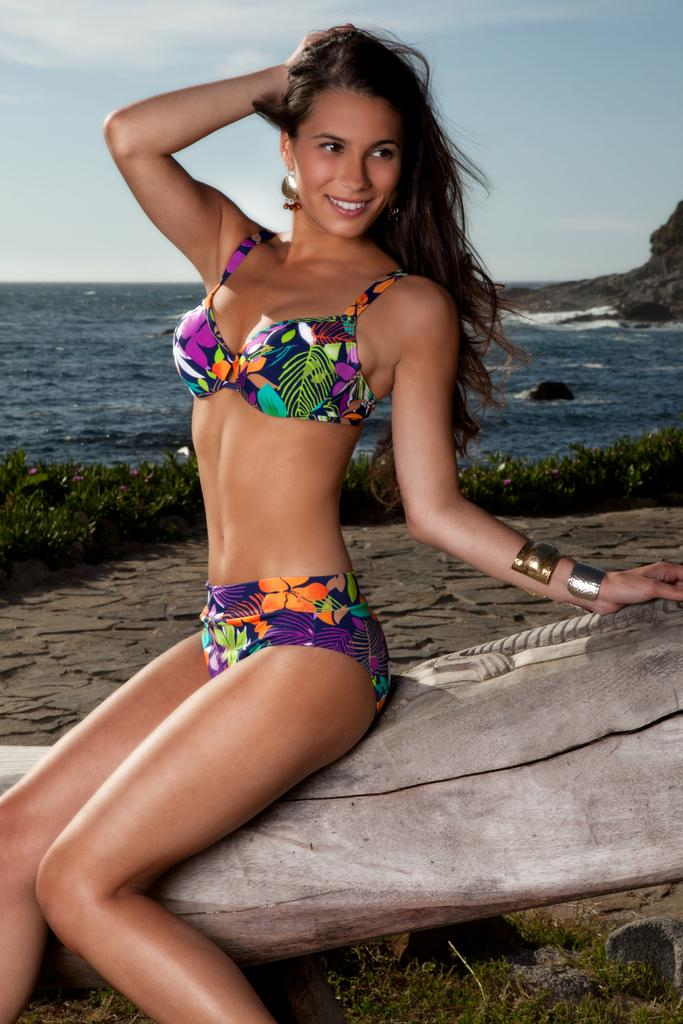Who is present in the image? There is a woman in the image. What is the woman doing in the image? The woman is sitting on a branch. What is the woman's facial expression in the image? The woman is smiling. What can be seen in the background of the image? There is sky, grass, and water visible in the background of the image. What suggestion does the woman make to the viewer in the image? There is no suggestion made by the woman in the image; she is simply sitting on a branch and smiling. 